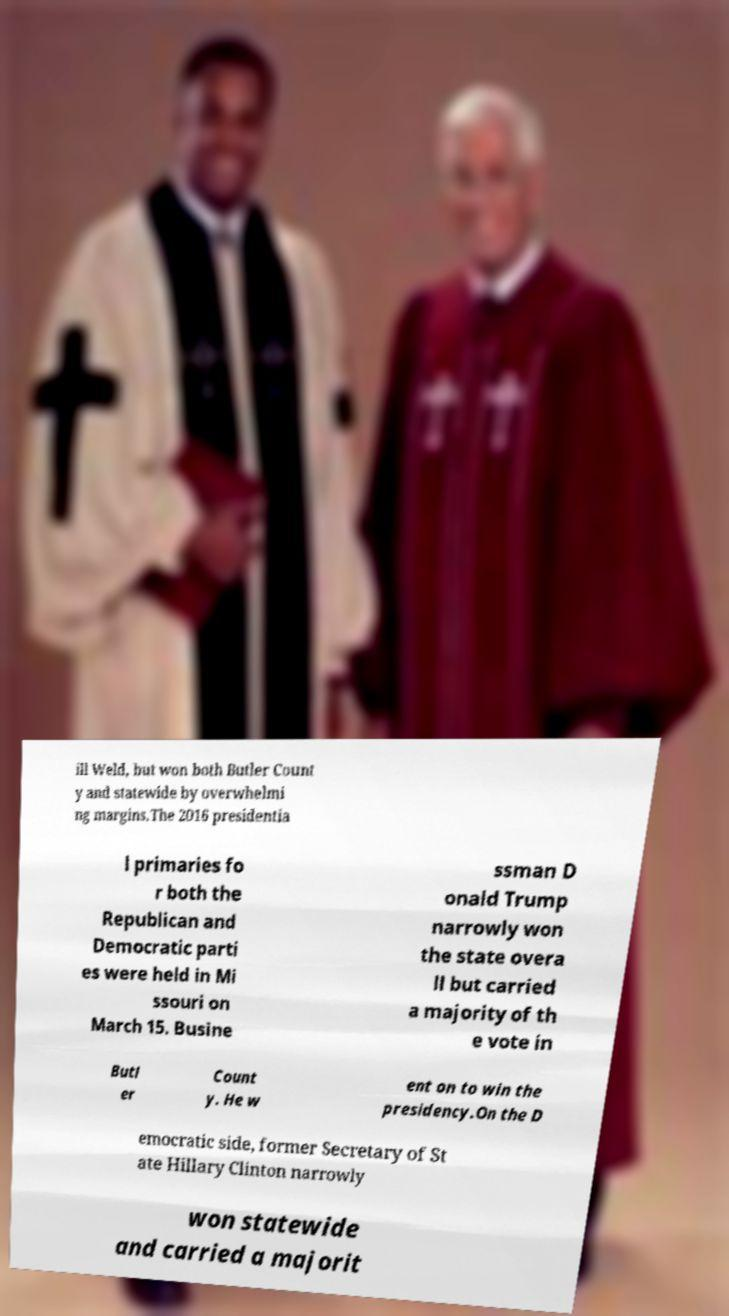Can you read and provide the text displayed in the image?This photo seems to have some interesting text. Can you extract and type it out for me? ill Weld, but won both Butler Count y and statewide by overwhelmi ng margins.The 2016 presidentia l primaries fo r both the Republican and Democratic parti es were held in Mi ssouri on March 15. Busine ssman D onald Trump narrowly won the state overa ll but carried a majority of th e vote in Butl er Count y. He w ent on to win the presidency.On the D emocratic side, former Secretary of St ate Hillary Clinton narrowly won statewide and carried a majorit 